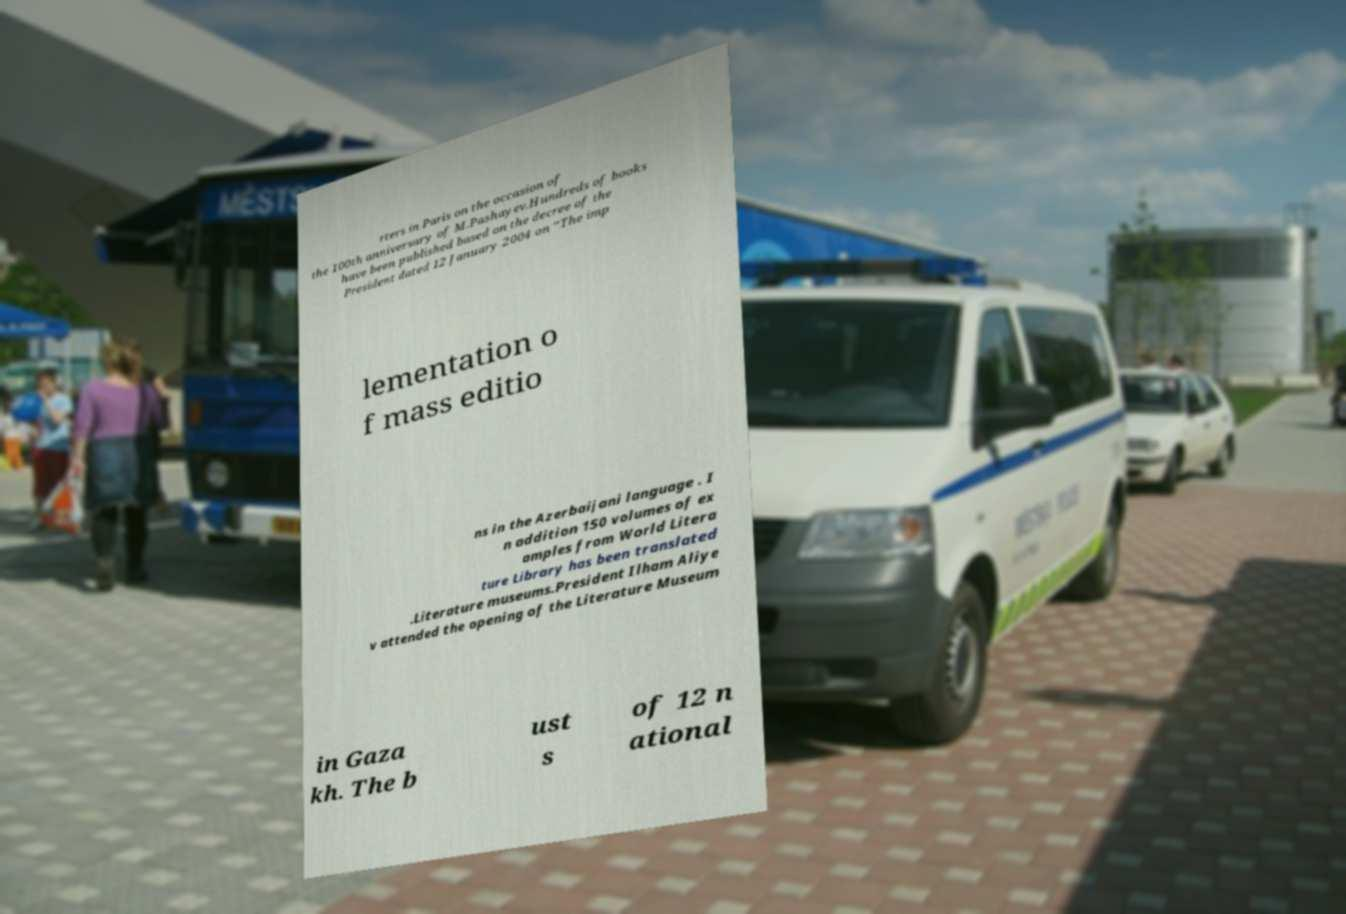I need the written content from this picture converted into text. Can you do that? rters in Paris on the occasion of the 100th anniversary of M.Pashayev.Hundreds of books have been published based on the decree of the President dated 12 January 2004 on “The imp lementation o f mass editio ns in the Azerbaijani language . I n addition 150 volumes of ex amples from World Litera ture Library has been translated .Literature museums.President Ilham Aliye v attended the opening of the Literature Museum in Gaza kh. The b ust s of 12 n ational 